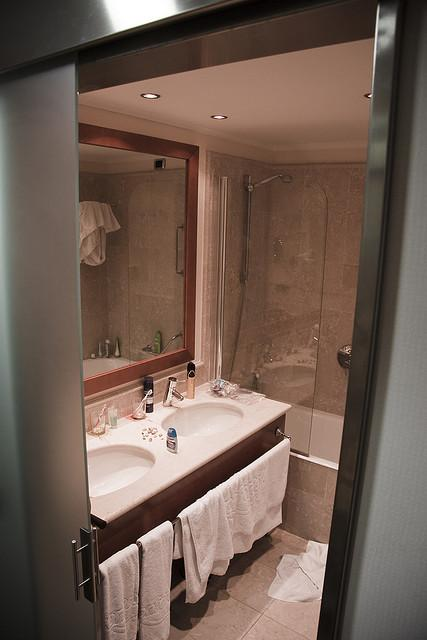How many people probably use this room? Please explain your reasoning. two. There are dual sinks that can be used at the same time, plus only a couple of toothbrushes. 